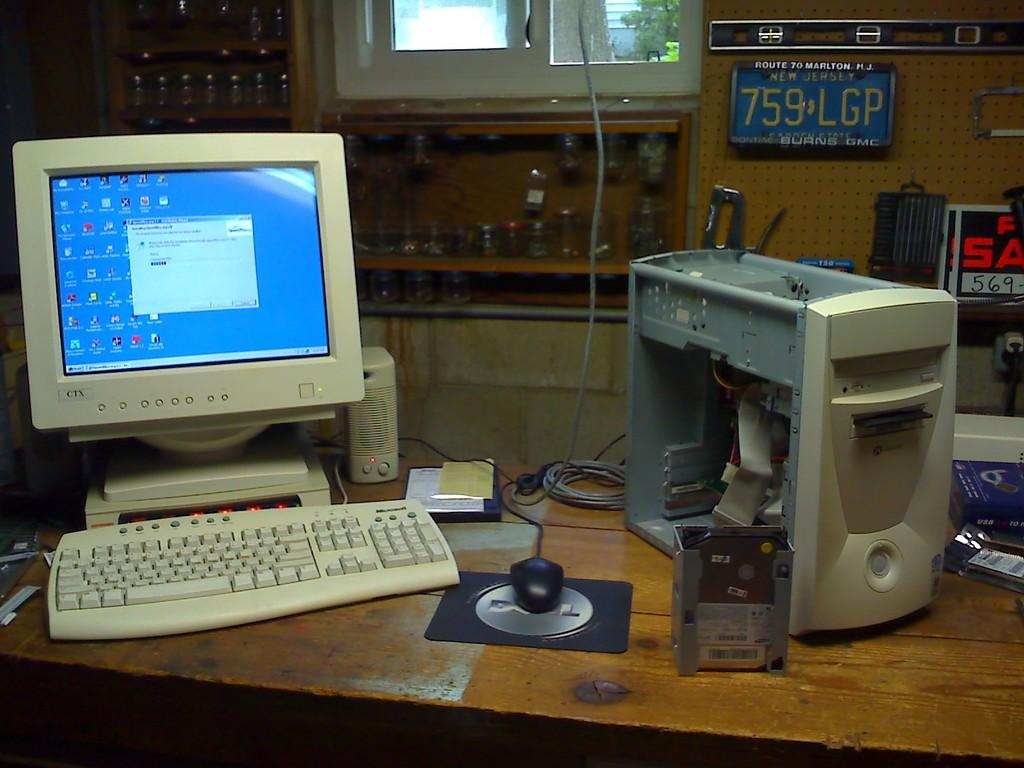<image>
Share a concise interpretation of the image provided. A CTX monitor is above a keyboard on a desk. 